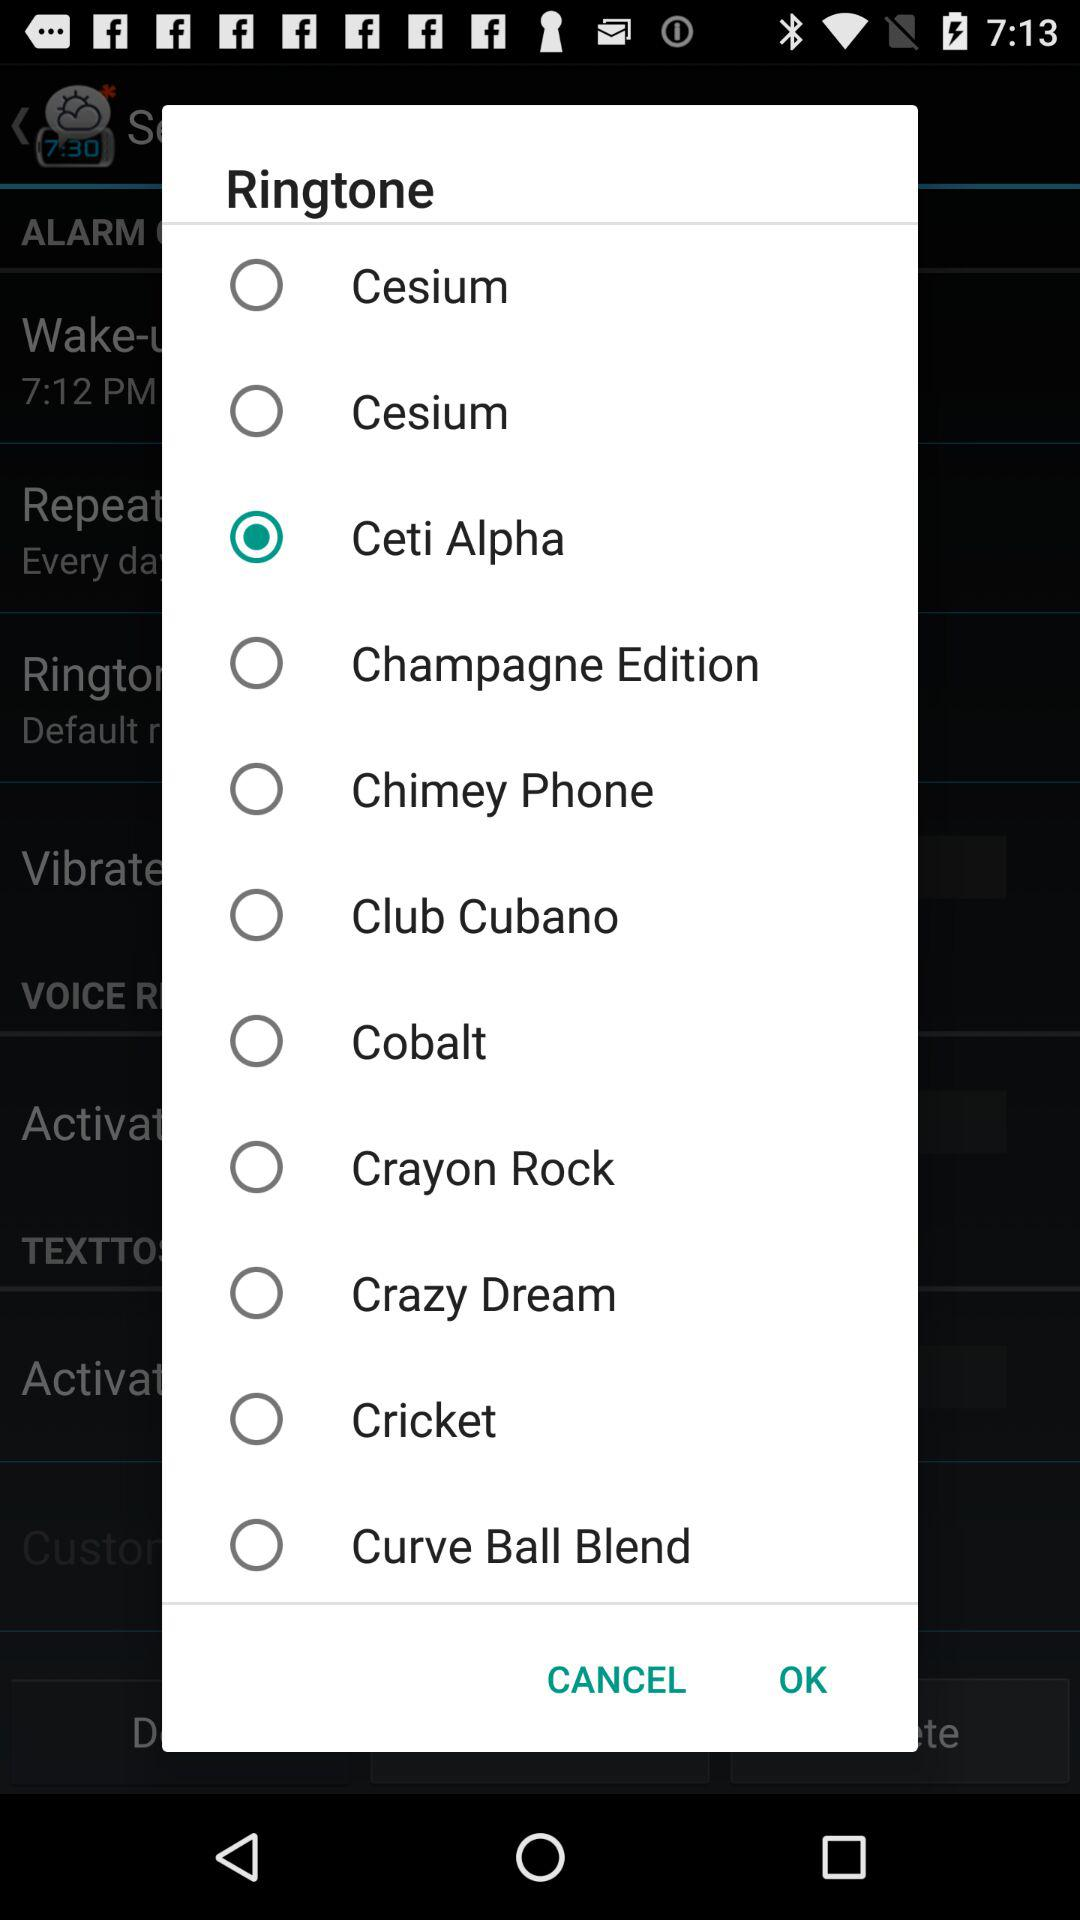What is the selected ringtone? The selected ringtone is "Ceti Alpha". 